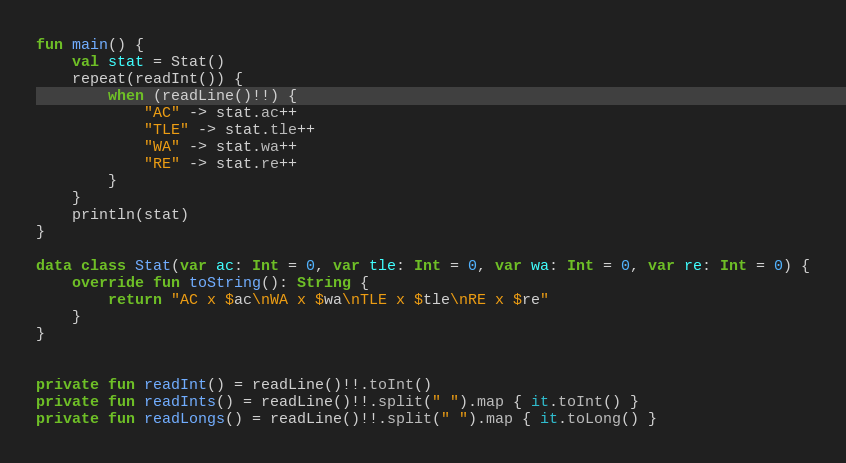Convert code to text. <code><loc_0><loc_0><loc_500><loc_500><_Kotlin_>fun main() {
    val stat = Stat()
    repeat(readInt()) {
        when (readLine()!!) {
            "AC" -> stat.ac++
            "TLE" -> stat.tle++
            "WA" -> stat.wa++
            "RE" -> stat.re++
        }
    }
    println(stat)
}

data class Stat(var ac: Int = 0, var tle: Int = 0, var wa: Int = 0, var re: Int = 0) {
    override fun toString(): String {
        return "AC x $ac\nWA x $wa\nTLE x $tle\nRE x $re"
    }
}


private fun readInt() = readLine()!!.toInt()
private fun readInts() = readLine()!!.split(" ").map { it.toInt() }
private fun readLongs() = readLine()!!.split(" ").map { it.toLong() }
</code> 